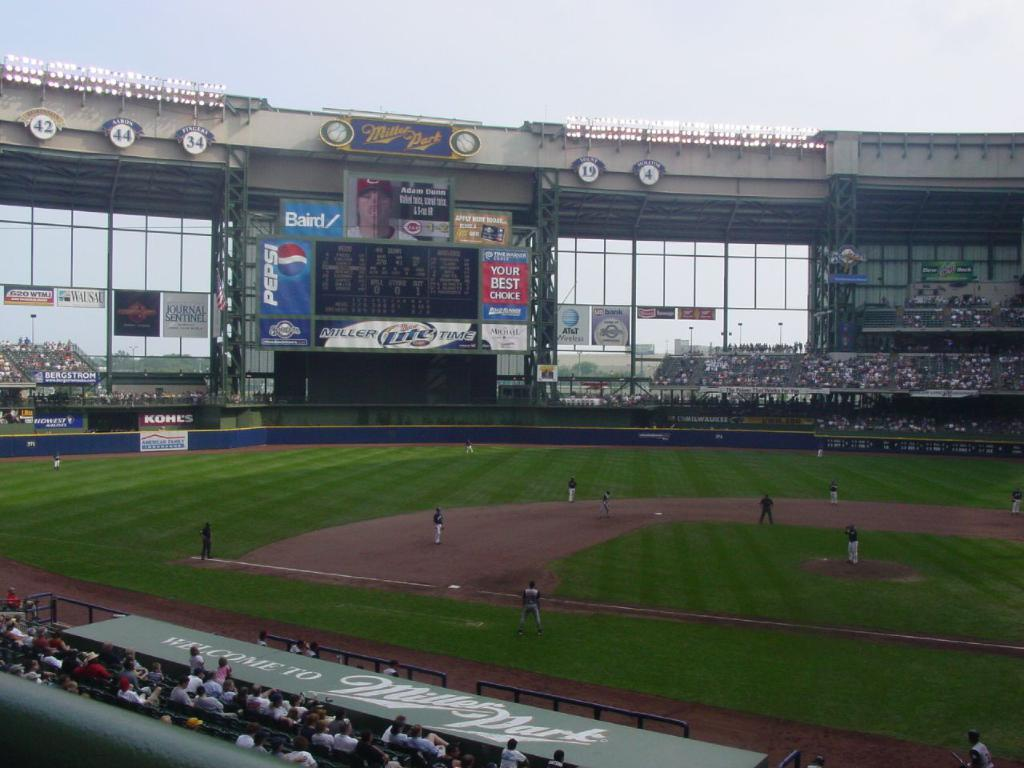Provide a one-sentence caption for the provided image. Baseball field that has an ad that says "Your Best Choice". 